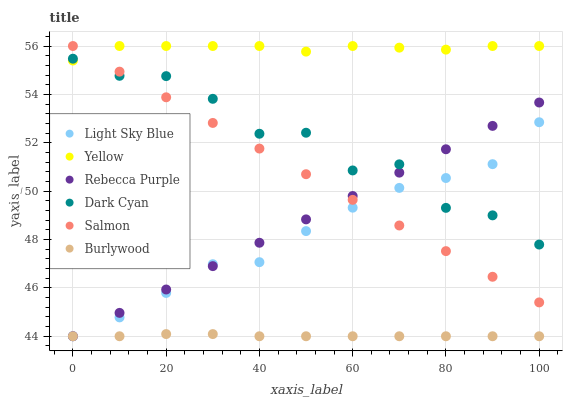Does Burlywood have the minimum area under the curve?
Answer yes or no. Yes. Does Yellow have the maximum area under the curve?
Answer yes or no. Yes. Does Salmon have the minimum area under the curve?
Answer yes or no. No. Does Salmon have the maximum area under the curve?
Answer yes or no. No. Is Rebecca Purple the smoothest?
Answer yes or no. Yes. Is Dark Cyan the roughest?
Answer yes or no. Yes. Is Salmon the smoothest?
Answer yes or no. No. Is Salmon the roughest?
Answer yes or no. No. Does Burlywood have the lowest value?
Answer yes or no. Yes. Does Salmon have the lowest value?
Answer yes or no. No. Does Yellow have the highest value?
Answer yes or no. Yes. Does Light Sky Blue have the highest value?
Answer yes or no. No. Is Burlywood less than Dark Cyan?
Answer yes or no. Yes. Is Yellow greater than Rebecca Purple?
Answer yes or no. Yes. Does Burlywood intersect Rebecca Purple?
Answer yes or no. Yes. Is Burlywood less than Rebecca Purple?
Answer yes or no. No. Is Burlywood greater than Rebecca Purple?
Answer yes or no. No. Does Burlywood intersect Dark Cyan?
Answer yes or no. No. 